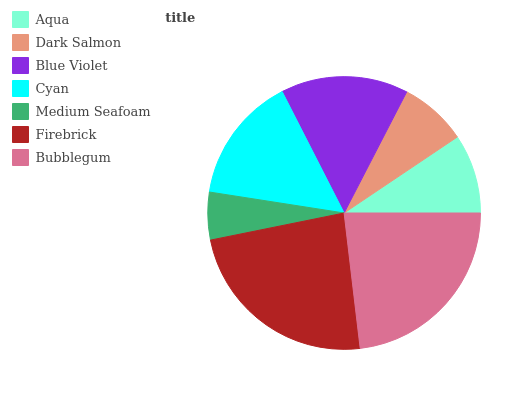Is Medium Seafoam the minimum?
Answer yes or no. Yes. Is Firebrick the maximum?
Answer yes or no. Yes. Is Dark Salmon the minimum?
Answer yes or no. No. Is Dark Salmon the maximum?
Answer yes or no. No. Is Aqua greater than Dark Salmon?
Answer yes or no. Yes. Is Dark Salmon less than Aqua?
Answer yes or no. Yes. Is Dark Salmon greater than Aqua?
Answer yes or no. No. Is Aqua less than Dark Salmon?
Answer yes or no. No. Is Cyan the high median?
Answer yes or no. Yes. Is Cyan the low median?
Answer yes or no. Yes. Is Medium Seafoam the high median?
Answer yes or no. No. Is Bubblegum the low median?
Answer yes or no. No. 